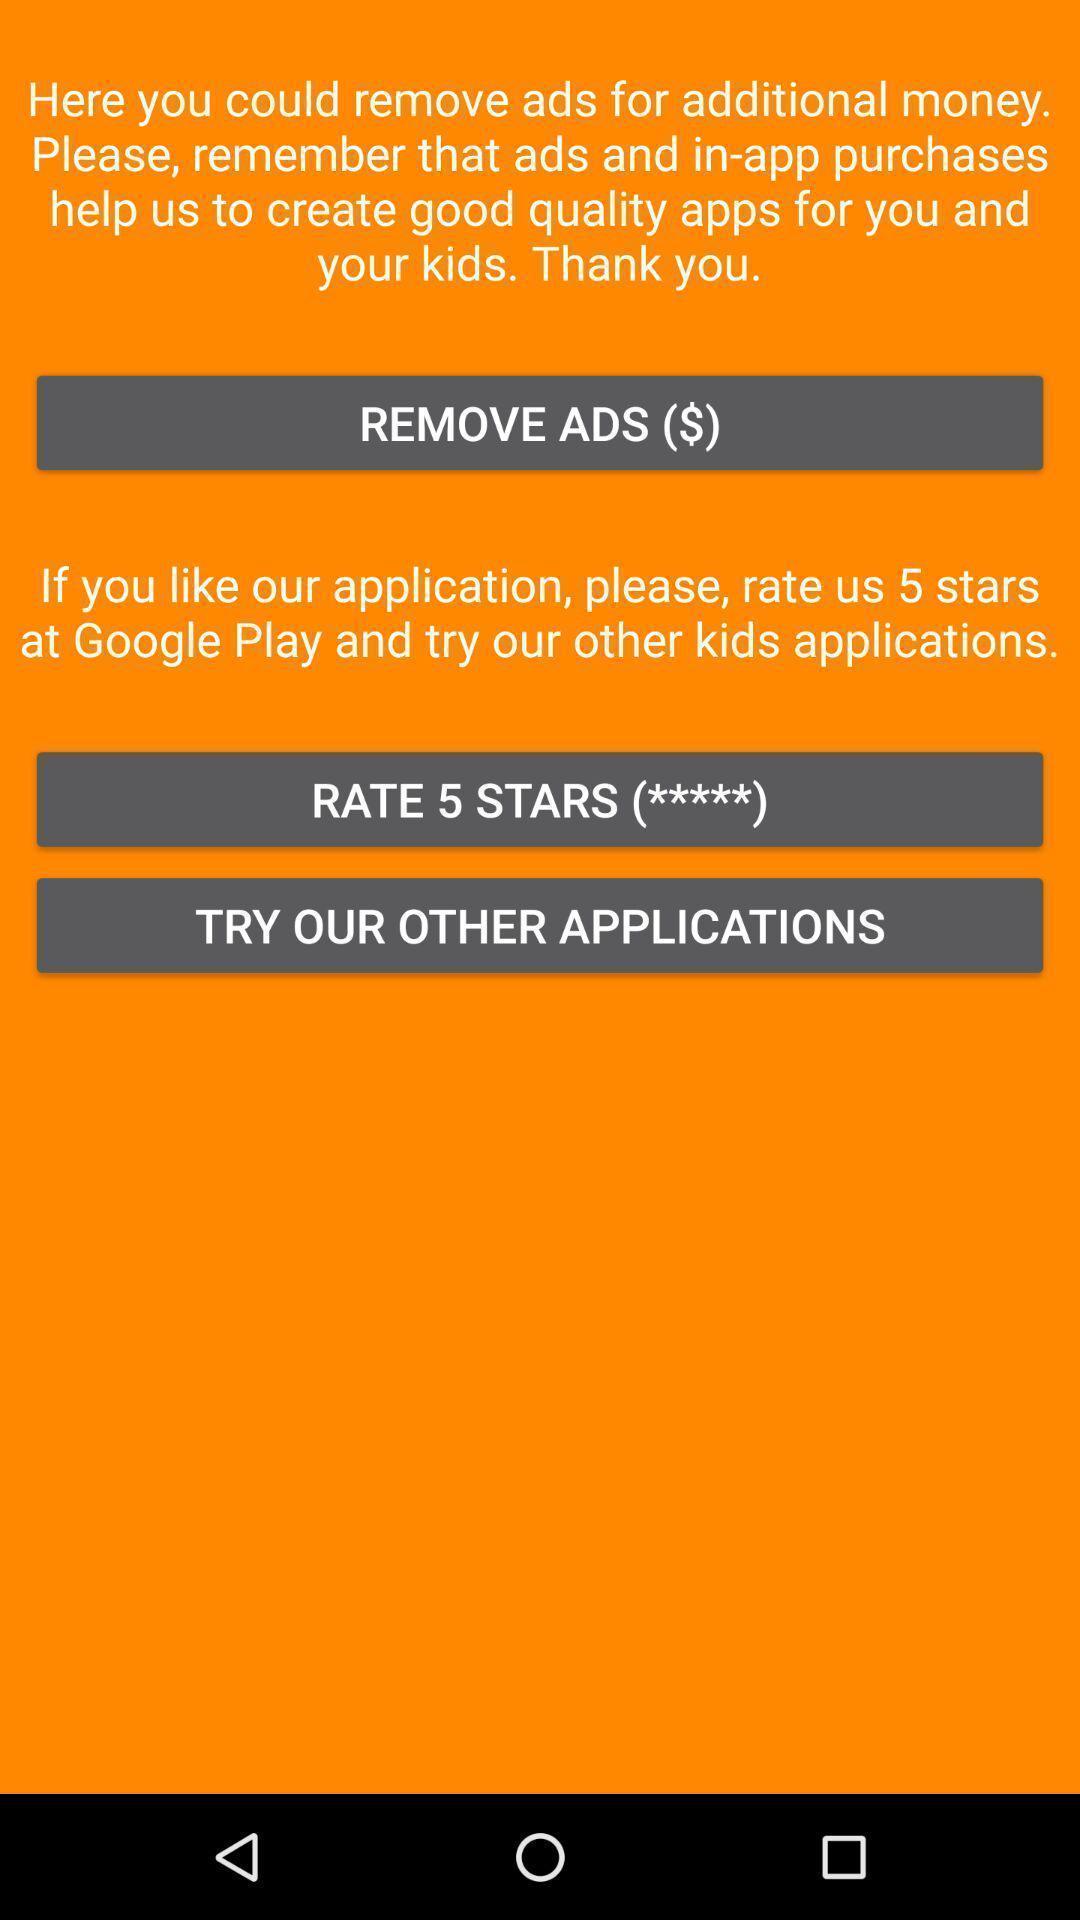What can you discern from this picture? Page with some information in an music application. 